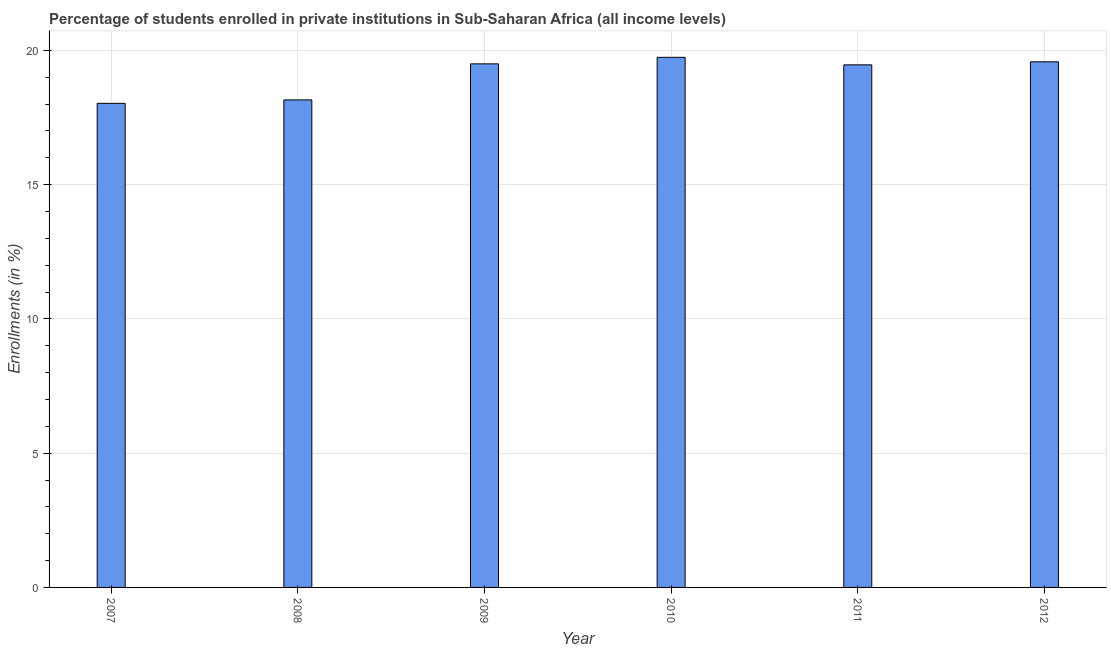Does the graph contain grids?
Ensure brevity in your answer.  Yes. What is the title of the graph?
Your answer should be compact. Percentage of students enrolled in private institutions in Sub-Saharan Africa (all income levels). What is the label or title of the X-axis?
Ensure brevity in your answer.  Year. What is the label or title of the Y-axis?
Ensure brevity in your answer.  Enrollments (in %). What is the enrollments in private institutions in 2008?
Your answer should be very brief. 18.16. Across all years, what is the maximum enrollments in private institutions?
Ensure brevity in your answer.  19.74. Across all years, what is the minimum enrollments in private institutions?
Your response must be concise. 18.03. In which year was the enrollments in private institutions maximum?
Give a very brief answer. 2010. In which year was the enrollments in private institutions minimum?
Offer a very short reply. 2007. What is the sum of the enrollments in private institutions?
Offer a very short reply. 114.47. What is the difference between the enrollments in private institutions in 2009 and 2012?
Keep it short and to the point. -0.08. What is the average enrollments in private institutions per year?
Provide a succinct answer. 19.08. What is the median enrollments in private institutions?
Keep it short and to the point. 19.48. In how many years, is the enrollments in private institutions greater than 1 %?
Keep it short and to the point. 6. What is the ratio of the enrollments in private institutions in 2007 to that in 2011?
Your response must be concise. 0.93. Is the enrollments in private institutions in 2009 less than that in 2012?
Offer a terse response. Yes. Is the difference between the enrollments in private institutions in 2011 and 2012 greater than the difference between any two years?
Provide a short and direct response. No. What is the difference between the highest and the second highest enrollments in private institutions?
Make the answer very short. 0.17. Is the sum of the enrollments in private institutions in 2009 and 2011 greater than the maximum enrollments in private institutions across all years?
Your answer should be very brief. Yes. What is the difference between the highest and the lowest enrollments in private institutions?
Your response must be concise. 1.71. In how many years, is the enrollments in private institutions greater than the average enrollments in private institutions taken over all years?
Give a very brief answer. 4. How many bars are there?
Your response must be concise. 6. Are the values on the major ticks of Y-axis written in scientific E-notation?
Provide a short and direct response. No. What is the Enrollments (in %) in 2007?
Provide a short and direct response. 18.03. What is the Enrollments (in %) of 2008?
Give a very brief answer. 18.16. What is the Enrollments (in %) of 2009?
Ensure brevity in your answer.  19.5. What is the Enrollments (in %) of 2010?
Your answer should be compact. 19.74. What is the Enrollments (in %) in 2011?
Ensure brevity in your answer.  19.46. What is the Enrollments (in %) in 2012?
Keep it short and to the point. 19.58. What is the difference between the Enrollments (in %) in 2007 and 2008?
Keep it short and to the point. -0.13. What is the difference between the Enrollments (in %) in 2007 and 2009?
Keep it short and to the point. -1.47. What is the difference between the Enrollments (in %) in 2007 and 2010?
Make the answer very short. -1.71. What is the difference between the Enrollments (in %) in 2007 and 2011?
Ensure brevity in your answer.  -1.43. What is the difference between the Enrollments (in %) in 2007 and 2012?
Offer a very short reply. -1.55. What is the difference between the Enrollments (in %) in 2008 and 2009?
Make the answer very short. -1.34. What is the difference between the Enrollments (in %) in 2008 and 2010?
Make the answer very short. -1.59. What is the difference between the Enrollments (in %) in 2008 and 2011?
Offer a very short reply. -1.31. What is the difference between the Enrollments (in %) in 2008 and 2012?
Give a very brief answer. -1.42. What is the difference between the Enrollments (in %) in 2009 and 2010?
Make the answer very short. -0.24. What is the difference between the Enrollments (in %) in 2009 and 2011?
Offer a terse response. 0.04. What is the difference between the Enrollments (in %) in 2009 and 2012?
Your response must be concise. -0.08. What is the difference between the Enrollments (in %) in 2010 and 2011?
Keep it short and to the point. 0.28. What is the difference between the Enrollments (in %) in 2010 and 2012?
Keep it short and to the point. 0.17. What is the difference between the Enrollments (in %) in 2011 and 2012?
Make the answer very short. -0.11. What is the ratio of the Enrollments (in %) in 2007 to that in 2008?
Your response must be concise. 0.99. What is the ratio of the Enrollments (in %) in 2007 to that in 2009?
Your response must be concise. 0.93. What is the ratio of the Enrollments (in %) in 2007 to that in 2011?
Give a very brief answer. 0.93. What is the ratio of the Enrollments (in %) in 2007 to that in 2012?
Provide a succinct answer. 0.92. What is the ratio of the Enrollments (in %) in 2008 to that in 2011?
Your answer should be very brief. 0.93. What is the ratio of the Enrollments (in %) in 2008 to that in 2012?
Your answer should be very brief. 0.93. What is the ratio of the Enrollments (in %) in 2009 to that in 2011?
Give a very brief answer. 1. What is the ratio of the Enrollments (in %) in 2009 to that in 2012?
Make the answer very short. 1. 